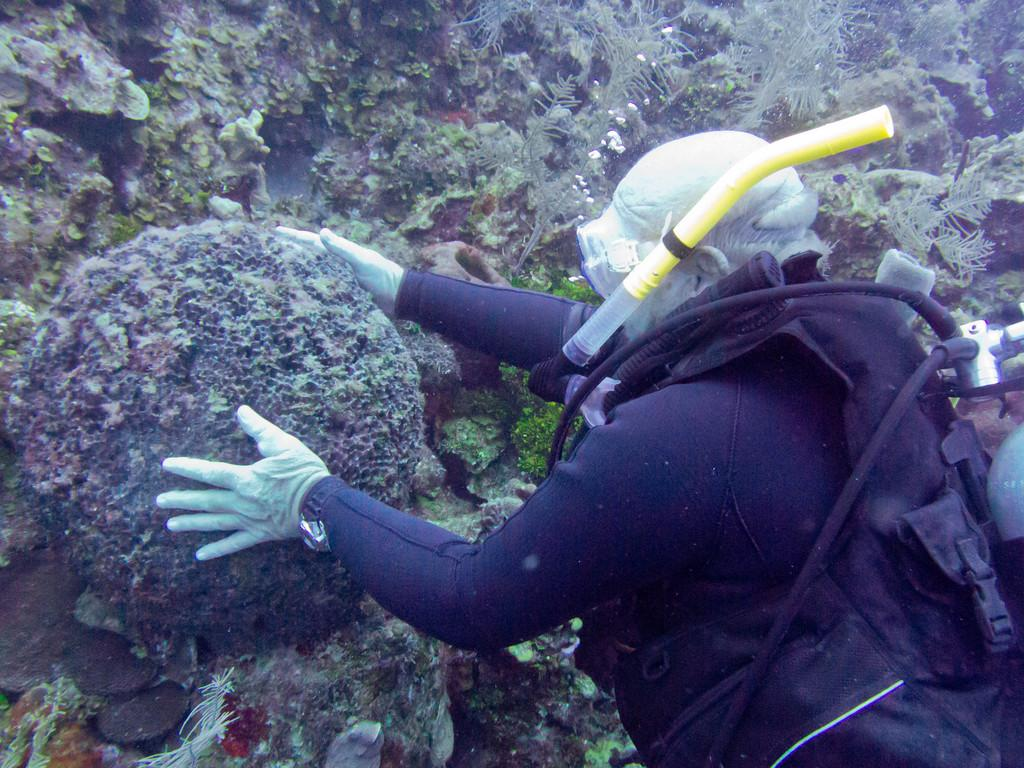What is the person in the image doing? The person in the image is swimming in the water. What is the person wearing while swimming? The person is wearing a black color dress. How many giants can be seen in the image? There are no giants present in the image. What type of breath does the person have while swimming? The image does not provide information about the person's breath while swimming. 